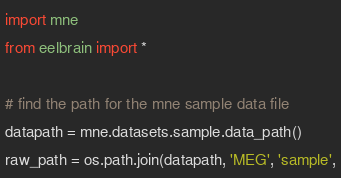Convert code to text. <code><loc_0><loc_0><loc_500><loc_500><_Python_>import mne
from eelbrain import *

# find the path for the mne sample data file
datapath = mne.datasets.sample.data_path()
raw_path = os.path.join(datapath, 'MEG', 'sample',</code> 